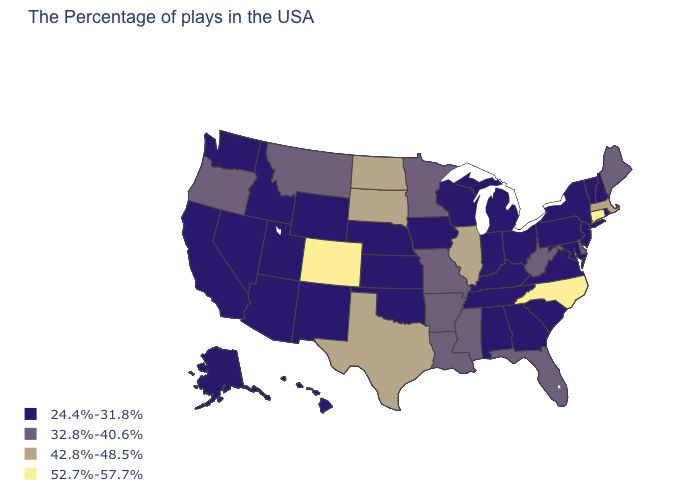Name the states that have a value in the range 52.7%-57.7%?
Quick response, please. Connecticut, North Carolina, Colorado. What is the value of Connecticut?
Quick response, please. 52.7%-57.7%. What is the value of North Dakota?
Keep it brief. 42.8%-48.5%. What is the value of Oklahoma?
Keep it brief. 24.4%-31.8%. Which states have the highest value in the USA?
Keep it brief. Connecticut, North Carolina, Colorado. Name the states that have a value in the range 24.4%-31.8%?
Be succinct. Rhode Island, New Hampshire, Vermont, New York, New Jersey, Maryland, Pennsylvania, Virginia, South Carolina, Ohio, Georgia, Michigan, Kentucky, Indiana, Alabama, Tennessee, Wisconsin, Iowa, Kansas, Nebraska, Oklahoma, Wyoming, New Mexico, Utah, Arizona, Idaho, Nevada, California, Washington, Alaska, Hawaii. What is the value of Vermont?
Concise answer only. 24.4%-31.8%. Name the states that have a value in the range 24.4%-31.8%?
Concise answer only. Rhode Island, New Hampshire, Vermont, New York, New Jersey, Maryland, Pennsylvania, Virginia, South Carolina, Ohio, Georgia, Michigan, Kentucky, Indiana, Alabama, Tennessee, Wisconsin, Iowa, Kansas, Nebraska, Oklahoma, Wyoming, New Mexico, Utah, Arizona, Idaho, Nevada, California, Washington, Alaska, Hawaii. Which states have the highest value in the USA?
Answer briefly. Connecticut, North Carolina, Colorado. Does Connecticut have the highest value in the Northeast?
Give a very brief answer. Yes. What is the value of Kansas?
Short answer required. 24.4%-31.8%. Does Minnesota have a lower value than Pennsylvania?
Answer briefly. No. What is the value of Idaho?
Be succinct. 24.4%-31.8%. What is the highest value in the MidWest ?
Answer briefly. 42.8%-48.5%. Which states hav the highest value in the MidWest?
Answer briefly. Illinois, South Dakota, North Dakota. 